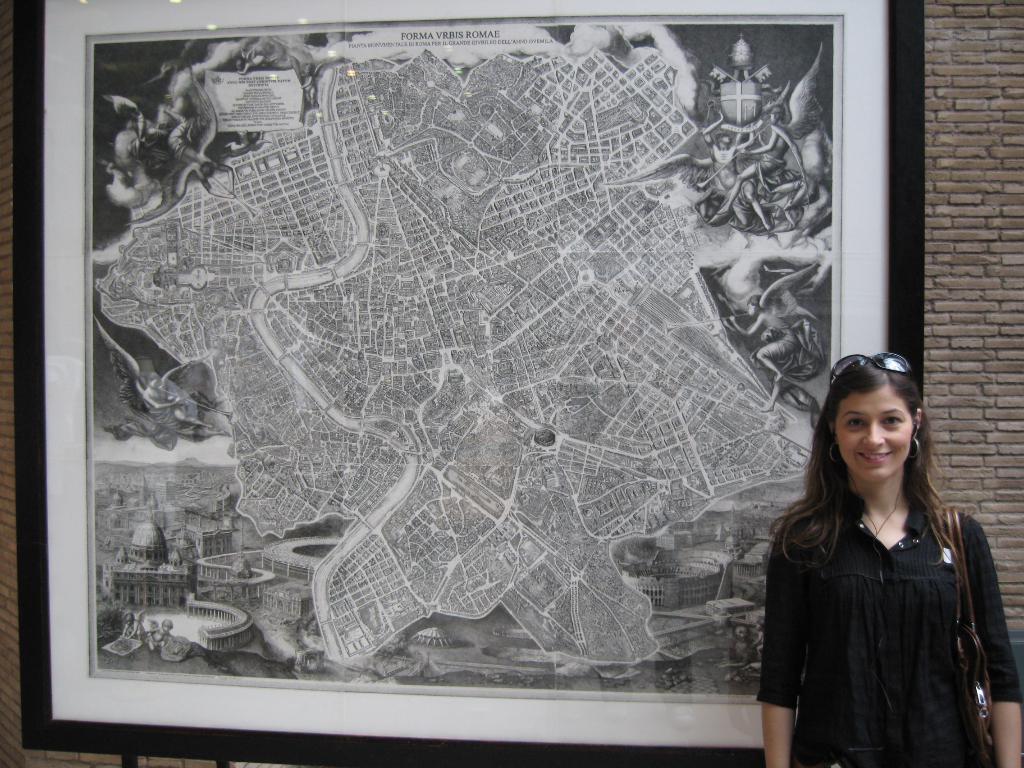How would you summarize this image in a sentence or two? In this picture I can see a woman is standing and smiling. The woman is wearing shades, black color dress and carrying a bag. Here I can see a photo of on the wall. On the photo I can see buildings, people and a map. The photo is black and white in color. 